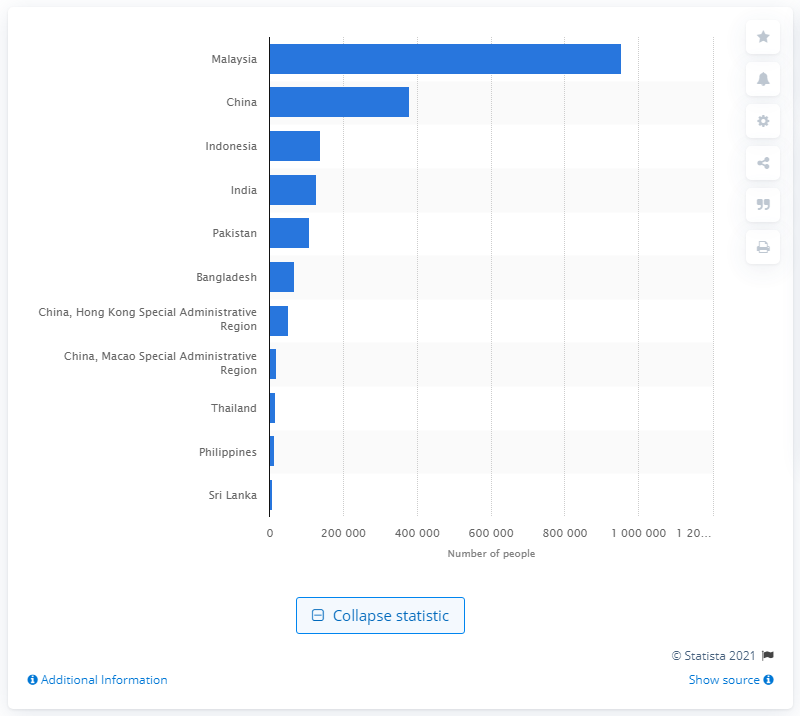Identify some key points in this picture. In 2019, approximately 952,261 Malaysians resided in Singapore. 